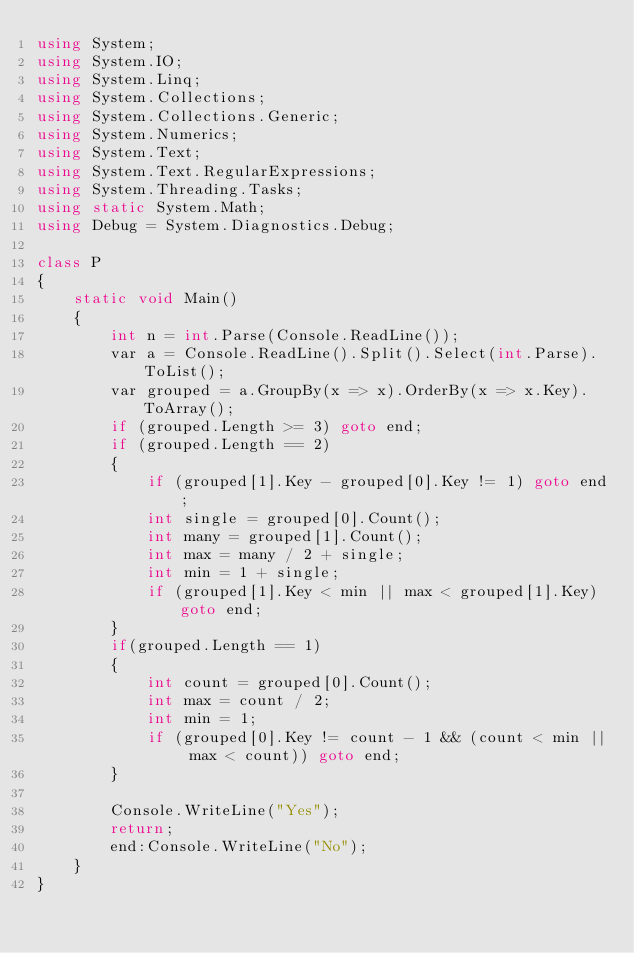<code> <loc_0><loc_0><loc_500><loc_500><_C#_>using System;
using System.IO;
using System.Linq;
using System.Collections;
using System.Collections.Generic;
using System.Numerics;
using System.Text;
using System.Text.RegularExpressions;
using System.Threading.Tasks;
using static System.Math;
using Debug = System.Diagnostics.Debug;

class P
{
    static void Main()
    {
        int n = int.Parse(Console.ReadLine());
        var a = Console.ReadLine().Split().Select(int.Parse).ToList();
        var grouped = a.GroupBy(x => x).OrderBy(x => x.Key).ToArray();
        if (grouped.Length >= 3) goto end;
        if (grouped.Length == 2)
        {
            if (grouped[1].Key - grouped[0].Key != 1) goto end;
            int single = grouped[0].Count();
            int many = grouped[1].Count();
            int max = many / 2 + single;
            int min = 1 + single;
            if (grouped[1].Key < min || max < grouped[1].Key) goto end;
        }
        if(grouped.Length == 1)
        {
            int count = grouped[0].Count();
            int max = count / 2;
            int min = 1;
            if (grouped[0].Key != count - 1 && (count < min || max < count)) goto end;
        }

        Console.WriteLine("Yes");
        return;
        end:Console.WriteLine("No");
    }
}
</code> 